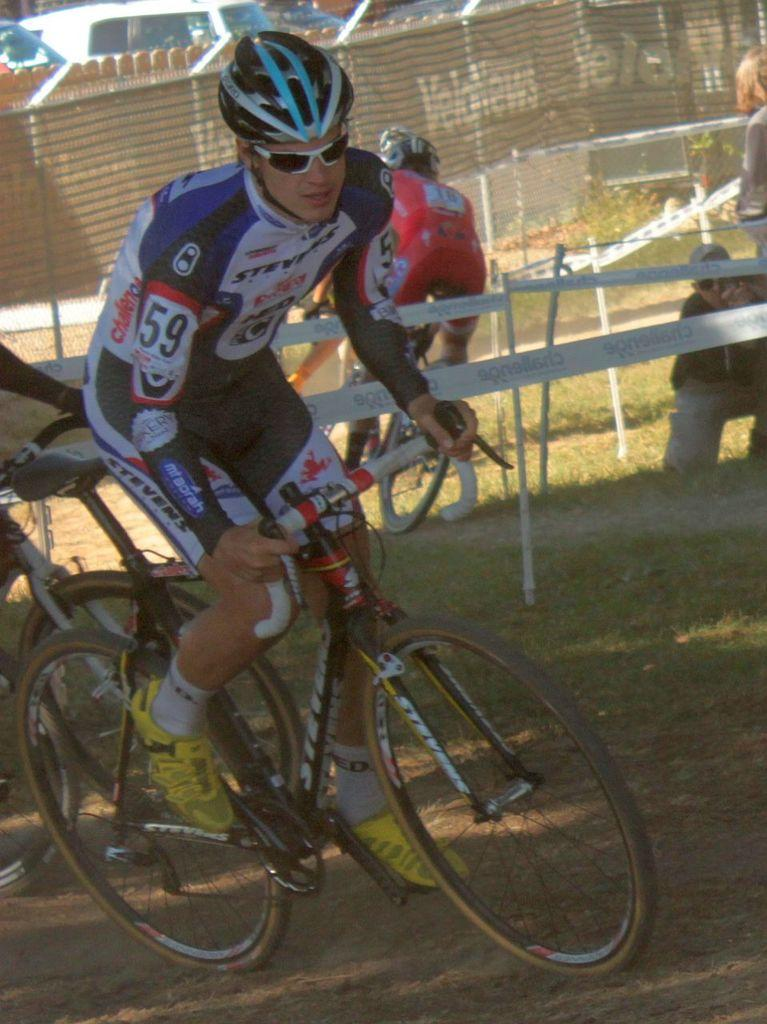What is the main subject of the image? There is a person in the image. What is the person doing in the image? The person is riding a bicycle. Can you describe the context of the image? The scene appears to be from a cycling competition. How many friends is the person riding with in the image? The image does not show any friends accompanying the person riding the bicycle. What type of route is the person cycling on in the image? The image does not provide information about the specific route the person is cycling on. 